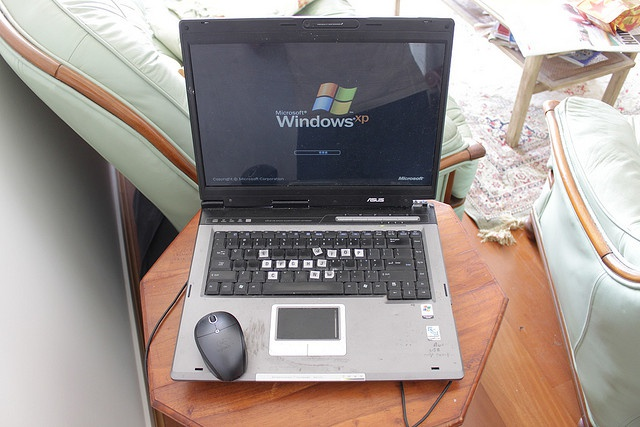Describe the objects in this image and their specific colors. I can see laptop in ivory, gray, black, lightgray, and darkgray tones, dining table in ivory, salmon, tan, and brown tones, couch in ivory, lightgray, darkgray, and gray tones, chair in ivory, white, darkgray, gray, and lightgray tones, and keyboard in ivory, gray, black, lightgray, and darkgray tones in this image. 